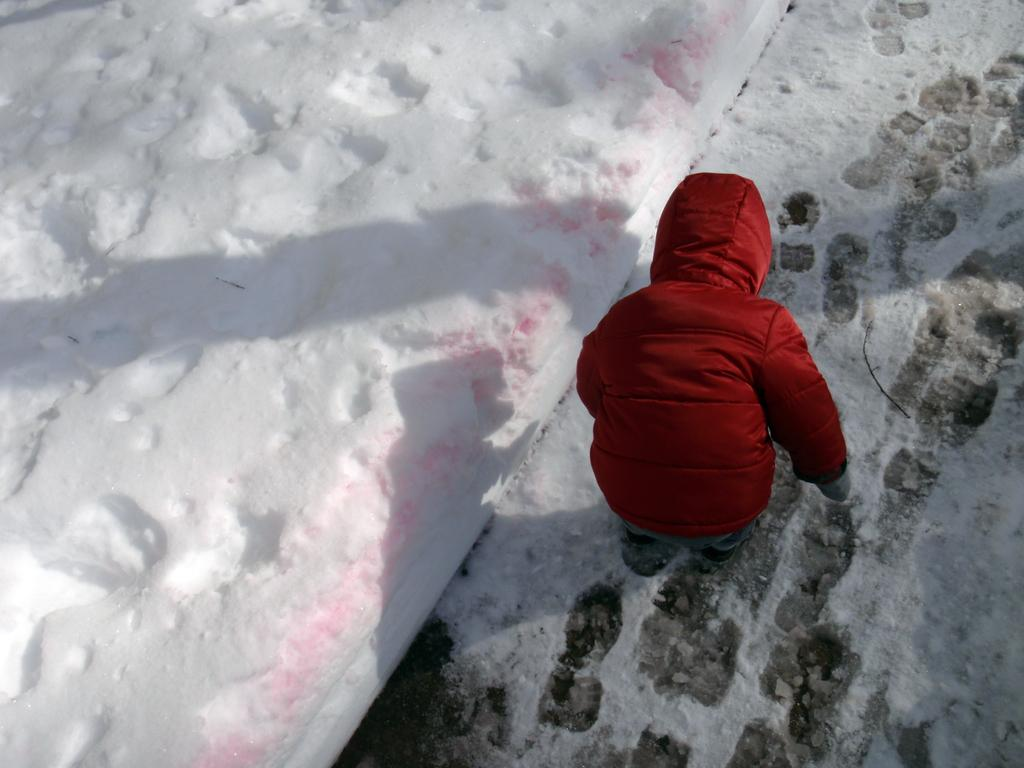What is the main subject of the image? The main subject of the image is a kid. What is the kid wearing in the image? The kid is wearing a jacket in the image. What type of weather condition can be observed in the image? There is snow visible in the image, indicating a cold or wintry weather condition. What type of twig can be seen in the kid's hand in the image? There is no twig visible in the kid's hand in the image. How does the heat affect the kid's clothing in the image? The image does not show any heat or warm weather conditions, so it cannot be determined how the heat would affect the kid's clothing. 